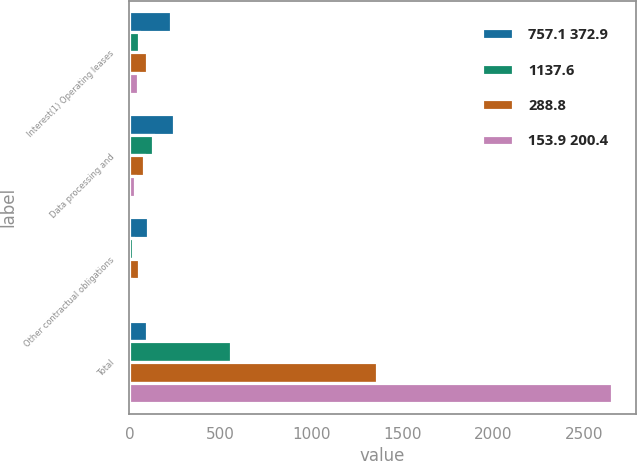Convert chart. <chart><loc_0><loc_0><loc_500><loc_500><stacked_bar_chart><ecel><fcel>Interest(1) Operating leases<fcel>Data processing and<fcel>Other contractual obligations<fcel>Total<nl><fcel>757.1 372.9<fcel>226.6<fcel>246.7<fcel>100.7<fcel>96.2<nl><fcel>1137.6<fcel>55<fcel>131.7<fcel>18.8<fcel>559.8<nl><fcel>288.8<fcel>96.2<fcel>78.9<fcel>52<fcel>1357.1<nl><fcel>153.9 200.4<fcel>46.4<fcel>28.4<fcel>10.6<fcel>2648.7<nl></chart> 